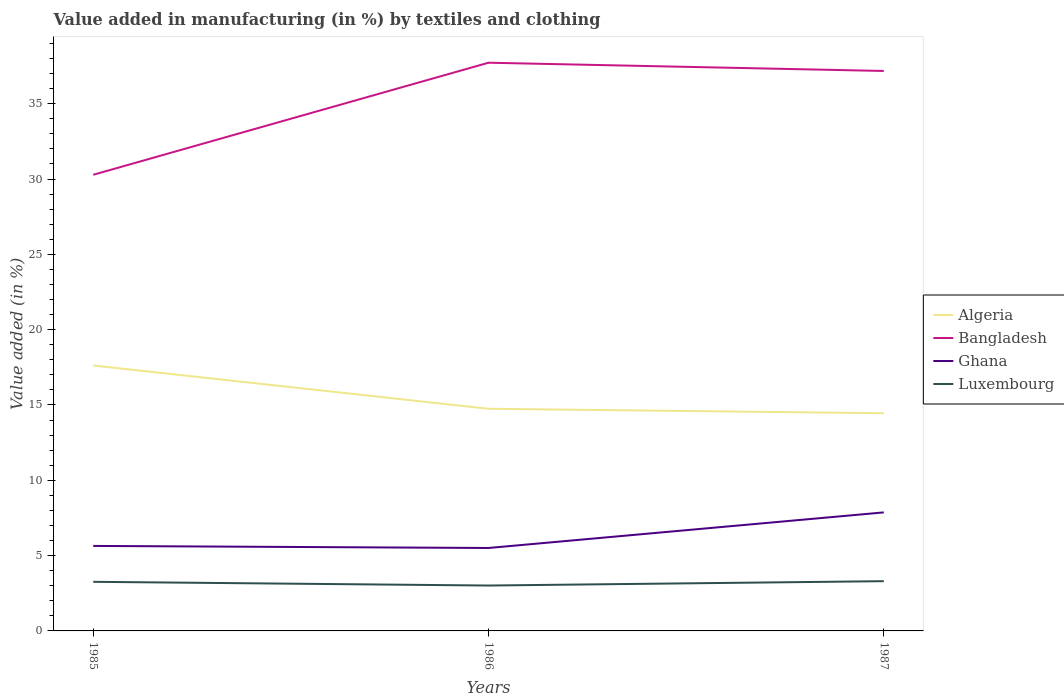How many different coloured lines are there?
Give a very brief answer. 4. Across all years, what is the maximum percentage of value added in manufacturing by textiles and clothing in Luxembourg?
Ensure brevity in your answer.  3.01. What is the total percentage of value added in manufacturing by textiles and clothing in Algeria in the graph?
Your answer should be very brief. 0.3. What is the difference between the highest and the second highest percentage of value added in manufacturing by textiles and clothing in Ghana?
Provide a short and direct response. 2.36. What is the difference between the highest and the lowest percentage of value added in manufacturing by textiles and clothing in Luxembourg?
Keep it short and to the point. 2. How many lines are there?
Ensure brevity in your answer.  4. How many years are there in the graph?
Ensure brevity in your answer.  3. Does the graph contain any zero values?
Keep it short and to the point. No. Does the graph contain grids?
Offer a very short reply. No. How many legend labels are there?
Give a very brief answer. 4. How are the legend labels stacked?
Keep it short and to the point. Vertical. What is the title of the graph?
Keep it short and to the point. Value added in manufacturing (in %) by textiles and clothing. What is the label or title of the Y-axis?
Keep it short and to the point. Value added (in %). What is the Value added (in %) of Algeria in 1985?
Ensure brevity in your answer.  17.62. What is the Value added (in %) of Bangladesh in 1985?
Your response must be concise. 30.28. What is the Value added (in %) in Ghana in 1985?
Provide a succinct answer. 5.64. What is the Value added (in %) in Luxembourg in 1985?
Keep it short and to the point. 3.26. What is the Value added (in %) in Algeria in 1986?
Offer a terse response. 14.75. What is the Value added (in %) in Bangladesh in 1986?
Offer a terse response. 37.72. What is the Value added (in %) of Ghana in 1986?
Offer a terse response. 5.51. What is the Value added (in %) of Luxembourg in 1986?
Ensure brevity in your answer.  3.01. What is the Value added (in %) in Algeria in 1987?
Your response must be concise. 14.45. What is the Value added (in %) in Bangladesh in 1987?
Your answer should be very brief. 37.18. What is the Value added (in %) of Ghana in 1987?
Offer a terse response. 7.87. What is the Value added (in %) in Luxembourg in 1987?
Give a very brief answer. 3.3. Across all years, what is the maximum Value added (in %) of Algeria?
Offer a terse response. 17.62. Across all years, what is the maximum Value added (in %) of Bangladesh?
Make the answer very short. 37.72. Across all years, what is the maximum Value added (in %) of Ghana?
Your answer should be compact. 7.87. Across all years, what is the maximum Value added (in %) of Luxembourg?
Keep it short and to the point. 3.3. Across all years, what is the minimum Value added (in %) of Algeria?
Offer a terse response. 14.45. Across all years, what is the minimum Value added (in %) of Bangladesh?
Make the answer very short. 30.28. Across all years, what is the minimum Value added (in %) in Ghana?
Your answer should be compact. 5.51. Across all years, what is the minimum Value added (in %) in Luxembourg?
Keep it short and to the point. 3.01. What is the total Value added (in %) of Algeria in the graph?
Your response must be concise. 46.82. What is the total Value added (in %) of Bangladesh in the graph?
Offer a terse response. 105.18. What is the total Value added (in %) of Ghana in the graph?
Offer a very short reply. 19.02. What is the total Value added (in %) in Luxembourg in the graph?
Your answer should be very brief. 9.58. What is the difference between the Value added (in %) in Algeria in 1985 and that in 1986?
Provide a short and direct response. 2.87. What is the difference between the Value added (in %) of Bangladesh in 1985 and that in 1986?
Offer a terse response. -7.44. What is the difference between the Value added (in %) in Ghana in 1985 and that in 1986?
Give a very brief answer. 0.14. What is the difference between the Value added (in %) of Luxembourg in 1985 and that in 1986?
Provide a short and direct response. 0.25. What is the difference between the Value added (in %) of Algeria in 1985 and that in 1987?
Your response must be concise. 3.17. What is the difference between the Value added (in %) in Bangladesh in 1985 and that in 1987?
Offer a terse response. -6.89. What is the difference between the Value added (in %) in Ghana in 1985 and that in 1987?
Your answer should be very brief. -2.23. What is the difference between the Value added (in %) in Luxembourg in 1985 and that in 1987?
Provide a short and direct response. -0.04. What is the difference between the Value added (in %) in Algeria in 1986 and that in 1987?
Provide a short and direct response. 0.3. What is the difference between the Value added (in %) of Bangladesh in 1986 and that in 1987?
Your answer should be compact. 0.55. What is the difference between the Value added (in %) of Ghana in 1986 and that in 1987?
Keep it short and to the point. -2.36. What is the difference between the Value added (in %) in Luxembourg in 1986 and that in 1987?
Keep it short and to the point. -0.29. What is the difference between the Value added (in %) in Algeria in 1985 and the Value added (in %) in Bangladesh in 1986?
Make the answer very short. -20.1. What is the difference between the Value added (in %) in Algeria in 1985 and the Value added (in %) in Ghana in 1986?
Provide a succinct answer. 12.12. What is the difference between the Value added (in %) in Algeria in 1985 and the Value added (in %) in Luxembourg in 1986?
Keep it short and to the point. 14.61. What is the difference between the Value added (in %) of Bangladesh in 1985 and the Value added (in %) of Ghana in 1986?
Provide a short and direct response. 24.78. What is the difference between the Value added (in %) in Bangladesh in 1985 and the Value added (in %) in Luxembourg in 1986?
Your answer should be compact. 27.27. What is the difference between the Value added (in %) in Ghana in 1985 and the Value added (in %) in Luxembourg in 1986?
Provide a succinct answer. 2.63. What is the difference between the Value added (in %) in Algeria in 1985 and the Value added (in %) in Bangladesh in 1987?
Ensure brevity in your answer.  -19.55. What is the difference between the Value added (in %) in Algeria in 1985 and the Value added (in %) in Ghana in 1987?
Provide a succinct answer. 9.75. What is the difference between the Value added (in %) in Algeria in 1985 and the Value added (in %) in Luxembourg in 1987?
Offer a terse response. 14.32. What is the difference between the Value added (in %) in Bangladesh in 1985 and the Value added (in %) in Ghana in 1987?
Provide a succinct answer. 22.41. What is the difference between the Value added (in %) of Bangladesh in 1985 and the Value added (in %) of Luxembourg in 1987?
Your answer should be very brief. 26.98. What is the difference between the Value added (in %) of Ghana in 1985 and the Value added (in %) of Luxembourg in 1987?
Ensure brevity in your answer.  2.34. What is the difference between the Value added (in %) in Algeria in 1986 and the Value added (in %) in Bangladesh in 1987?
Provide a succinct answer. -22.43. What is the difference between the Value added (in %) in Algeria in 1986 and the Value added (in %) in Ghana in 1987?
Keep it short and to the point. 6.88. What is the difference between the Value added (in %) in Algeria in 1986 and the Value added (in %) in Luxembourg in 1987?
Your response must be concise. 11.45. What is the difference between the Value added (in %) of Bangladesh in 1986 and the Value added (in %) of Ghana in 1987?
Keep it short and to the point. 29.86. What is the difference between the Value added (in %) of Bangladesh in 1986 and the Value added (in %) of Luxembourg in 1987?
Your response must be concise. 34.42. What is the difference between the Value added (in %) in Ghana in 1986 and the Value added (in %) in Luxembourg in 1987?
Your answer should be very brief. 2.2. What is the average Value added (in %) of Algeria per year?
Provide a short and direct response. 15.61. What is the average Value added (in %) in Bangladesh per year?
Ensure brevity in your answer.  35.06. What is the average Value added (in %) of Ghana per year?
Provide a short and direct response. 6.34. What is the average Value added (in %) in Luxembourg per year?
Offer a terse response. 3.19. In the year 1985, what is the difference between the Value added (in %) in Algeria and Value added (in %) in Bangladesh?
Give a very brief answer. -12.66. In the year 1985, what is the difference between the Value added (in %) of Algeria and Value added (in %) of Ghana?
Your answer should be very brief. 11.98. In the year 1985, what is the difference between the Value added (in %) in Algeria and Value added (in %) in Luxembourg?
Ensure brevity in your answer.  14.36. In the year 1985, what is the difference between the Value added (in %) of Bangladesh and Value added (in %) of Ghana?
Offer a terse response. 24.64. In the year 1985, what is the difference between the Value added (in %) of Bangladesh and Value added (in %) of Luxembourg?
Provide a succinct answer. 27.02. In the year 1985, what is the difference between the Value added (in %) of Ghana and Value added (in %) of Luxembourg?
Your response must be concise. 2.38. In the year 1986, what is the difference between the Value added (in %) of Algeria and Value added (in %) of Bangladesh?
Offer a terse response. -22.97. In the year 1986, what is the difference between the Value added (in %) of Algeria and Value added (in %) of Ghana?
Your answer should be compact. 9.24. In the year 1986, what is the difference between the Value added (in %) of Algeria and Value added (in %) of Luxembourg?
Your answer should be compact. 11.74. In the year 1986, what is the difference between the Value added (in %) in Bangladesh and Value added (in %) in Ghana?
Your answer should be very brief. 32.22. In the year 1986, what is the difference between the Value added (in %) in Bangladesh and Value added (in %) in Luxembourg?
Provide a succinct answer. 34.71. In the year 1986, what is the difference between the Value added (in %) in Ghana and Value added (in %) in Luxembourg?
Ensure brevity in your answer.  2.49. In the year 1987, what is the difference between the Value added (in %) of Algeria and Value added (in %) of Bangladesh?
Ensure brevity in your answer.  -22.72. In the year 1987, what is the difference between the Value added (in %) in Algeria and Value added (in %) in Ghana?
Offer a very short reply. 6.58. In the year 1987, what is the difference between the Value added (in %) in Algeria and Value added (in %) in Luxembourg?
Offer a very short reply. 11.15. In the year 1987, what is the difference between the Value added (in %) in Bangladesh and Value added (in %) in Ghana?
Provide a succinct answer. 29.31. In the year 1987, what is the difference between the Value added (in %) in Bangladesh and Value added (in %) in Luxembourg?
Give a very brief answer. 33.87. In the year 1987, what is the difference between the Value added (in %) in Ghana and Value added (in %) in Luxembourg?
Provide a short and direct response. 4.57. What is the ratio of the Value added (in %) in Algeria in 1985 to that in 1986?
Offer a very short reply. 1.19. What is the ratio of the Value added (in %) in Bangladesh in 1985 to that in 1986?
Make the answer very short. 0.8. What is the ratio of the Value added (in %) of Ghana in 1985 to that in 1986?
Offer a very short reply. 1.02. What is the ratio of the Value added (in %) of Luxembourg in 1985 to that in 1986?
Give a very brief answer. 1.08. What is the ratio of the Value added (in %) in Algeria in 1985 to that in 1987?
Your answer should be very brief. 1.22. What is the ratio of the Value added (in %) of Bangladesh in 1985 to that in 1987?
Ensure brevity in your answer.  0.81. What is the ratio of the Value added (in %) of Ghana in 1985 to that in 1987?
Make the answer very short. 0.72. What is the ratio of the Value added (in %) in Luxembourg in 1985 to that in 1987?
Your answer should be very brief. 0.99. What is the ratio of the Value added (in %) in Algeria in 1986 to that in 1987?
Offer a very short reply. 1.02. What is the ratio of the Value added (in %) in Bangladesh in 1986 to that in 1987?
Your response must be concise. 1.01. What is the ratio of the Value added (in %) of Ghana in 1986 to that in 1987?
Your answer should be compact. 0.7. What is the ratio of the Value added (in %) of Luxembourg in 1986 to that in 1987?
Your answer should be compact. 0.91. What is the difference between the highest and the second highest Value added (in %) in Algeria?
Make the answer very short. 2.87. What is the difference between the highest and the second highest Value added (in %) of Bangladesh?
Your response must be concise. 0.55. What is the difference between the highest and the second highest Value added (in %) of Ghana?
Provide a short and direct response. 2.23. What is the difference between the highest and the second highest Value added (in %) in Luxembourg?
Provide a short and direct response. 0.04. What is the difference between the highest and the lowest Value added (in %) of Algeria?
Provide a short and direct response. 3.17. What is the difference between the highest and the lowest Value added (in %) of Bangladesh?
Make the answer very short. 7.44. What is the difference between the highest and the lowest Value added (in %) of Ghana?
Provide a succinct answer. 2.36. What is the difference between the highest and the lowest Value added (in %) of Luxembourg?
Your answer should be compact. 0.29. 